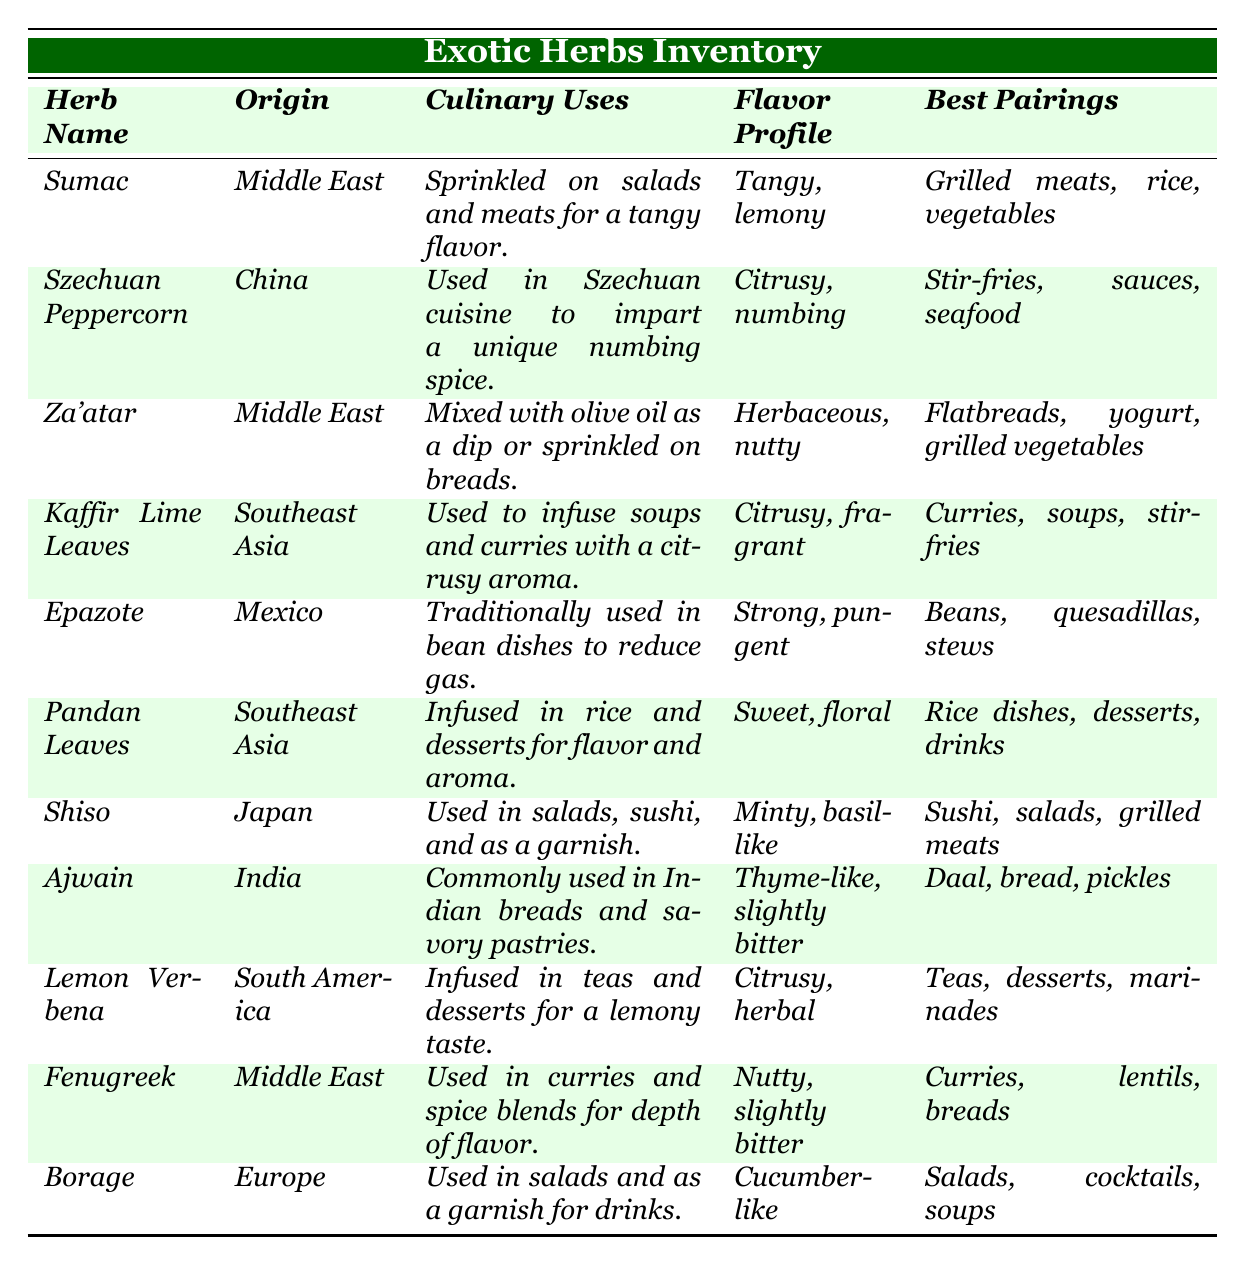What culinary uses does Za'atar have? The table states that Za'atar is mixed with olive oil as a dip or sprinkled on breads.
Answer: Mixed with olive oil as a dip or sprinkled on breads Which herb has a citrusy flavor profile? Two herbs display a citrusy flavor profile: Kaffir Lime Leaves and Lemon Verbena, as indicated in the table.
Answer: Kaffir Lime Leaves and Lemon Verbena Is the Szechuan Peppercorn used in salads? The table specifies that Szechuan Peppercorn is primarily used in Szechuan cuisine for stir-fries, sauces, and seafood, not salads.
Answer: No What are the best pairings for Pandan Leaves? The table lists rice dishes, desserts, and drinks as the best pairings for Pandan Leaves.
Answer: Rice dishes, desserts, drinks How many herbs are listed from the Middle East? By counting the rows in the table, three herbs (Sumac, Za'atar, and Fenugreek) originate from the Middle East.
Answer: Three Which herb has the strongest flavor profile? Epazote is noted for having a strong, pungent flavor profile among the herbs listed in the table.
Answer: Epazote What are common uses for Shiso? The table indicates that Shiso is used in salads, sushi, and as a garnish.
Answer: Salads, sushi, garnish If you were making a curry, which two herbs from this table could you use? The table notes that both Kaffir Lime Leaves and Fenugreek are recommended for use in curries.
Answer: Kaffir Lime Leaves and Fenugreek What is the origin of Borage? According to the table, Borage originates from Europe.
Answer: Europe Based on the table, which herb is specifically used to reduce gas in bean dishes? Epazote is cited in the table as traditionally used in bean dishes to reduce gas.
Answer: Epazote What herb has a flavor profile described as "herbaceous, nutty"? The table reveals that Za'atar has a flavor profile described as "herbaceous, nutty."
Answer: Za'atar How would you pair herbs for a dish that includes grilled meats? From the table, both Sumac and Shiso are indicated as best pairings for grilled meats.
Answer: Sumac and Shiso Which herb can be used in drinks as a garnish? Borage is noted for being used as a garnish in drinks, according to the table.
Answer: Borage Which herbs from the table have a sweet flavor profile? The table identifies Pandan Leaves as the only herb with a sweet, floral flavor profile.
Answer: Pandan Leaves What would you pair with lemon verbena in desserts? The best pairings for Lemon Verbena listed in the table include teas, desserts, and marinades, so desserts would pair well.
Answer: Desserts Are there any herbs used in both savory dishes and teas? Lemon Verbena is utilized in both teas and desserts, indicating it serves two culinary purposes.
Answer: Yes, Lemon Verbena 